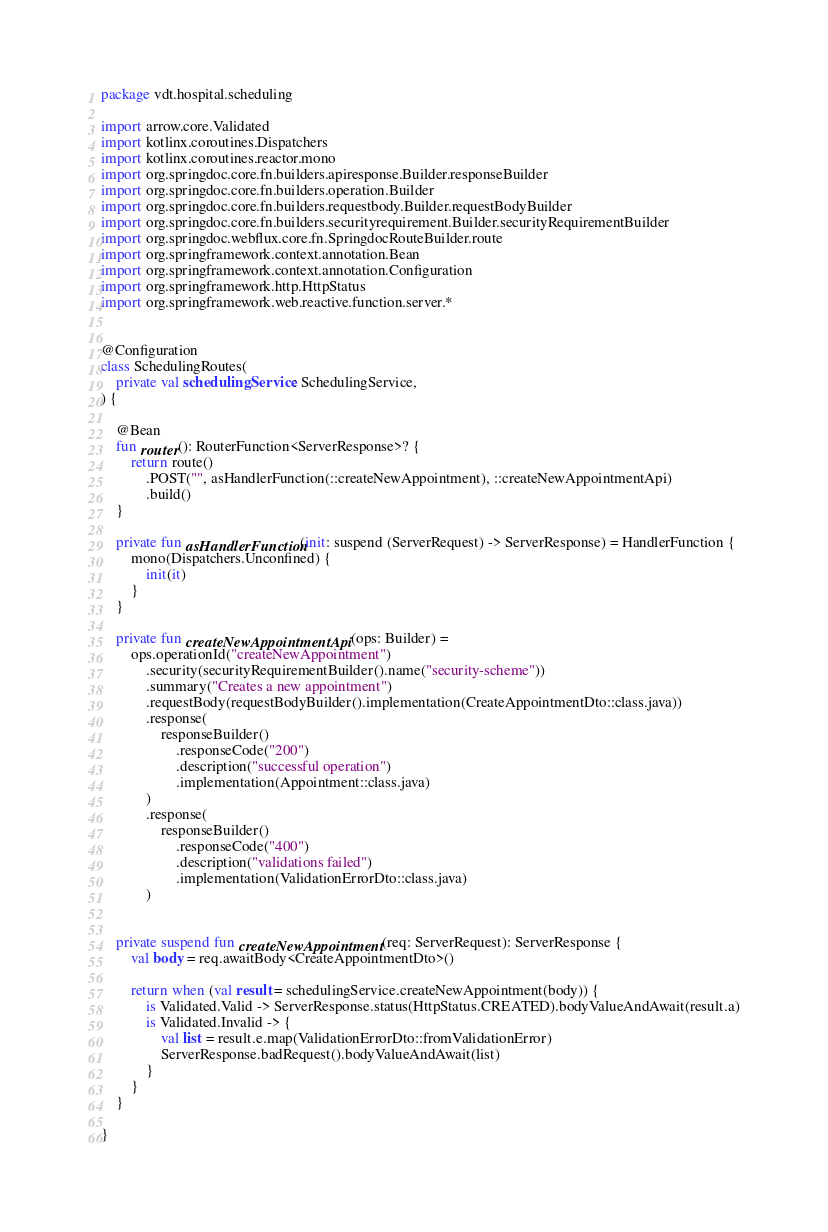<code> <loc_0><loc_0><loc_500><loc_500><_Kotlin_>package vdt.hospital.scheduling

import arrow.core.Validated
import kotlinx.coroutines.Dispatchers
import kotlinx.coroutines.reactor.mono
import org.springdoc.core.fn.builders.apiresponse.Builder.responseBuilder
import org.springdoc.core.fn.builders.operation.Builder
import org.springdoc.core.fn.builders.requestbody.Builder.requestBodyBuilder
import org.springdoc.core.fn.builders.securityrequirement.Builder.securityRequirementBuilder
import org.springdoc.webflux.core.fn.SpringdocRouteBuilder.route
import org.springframework.context.annotation.Bean
import org.springframework.context.annotation.Configuration
import org.springframework.http.HttpStatus
import org.springframework.web.reactive.function.server.*


@Configuration
class SchedulingRoutes(
    private val schedulingService: SchedulingService,
) {

    @Bean
    fun router(): RouterFunction<ServerResponse>? {
        return route()
            .POST("", asHandlerFunction(::createNewAppointment), ::createNewAppointmentApi)
            .build()
    }

    private fun asHandlerFunction(init: suspend (ServerRequest) -> ServerResponse) = HandlerFunction {
        mono(Dispatchers.Unconfined) {
            init(it)
        }
    }

    private fun createNewAppointmentApi(ops: Builder) =
        ops.operationId("createNewAppointment")
            .security(securityRequirementBuilder().name("security-scheme"))
            .summary("Creates a new appointment")
            .requestBody(requestBodyBuilder().implementation(CreateAppointmentDto::class.java))
            .response(
                responseBuilder()
                    .responseCode("200")
                    .description("successful operation")
                    .implementation(Appointment::class.java)
            )
            .response(
                responseBuilder()
                    .responseCode("400")
                    .description("validations failed")
                    .implementation(ValidationErrorDto::class.java)
            )


    private suspend fun createNewAppointment(req: ServerRequest): ServerResponse {
        val body = req.awaitBody<CreateAppointmentDto>()

        return when (val result = schedulingService.createNewAppointment(body)) {
            is Validated.Valid -> ServerResponse.status(HttpStatus.CREATED).bodyValueAndAwait(result.a)
            is Validated.Invalid -> {
                val list = result.e.map(ValidationErrorDto::fromValidationError)
                ServerResponse.badRequest().bodyValueAndAwait(list)
            }
        }
    }

}
</code> 